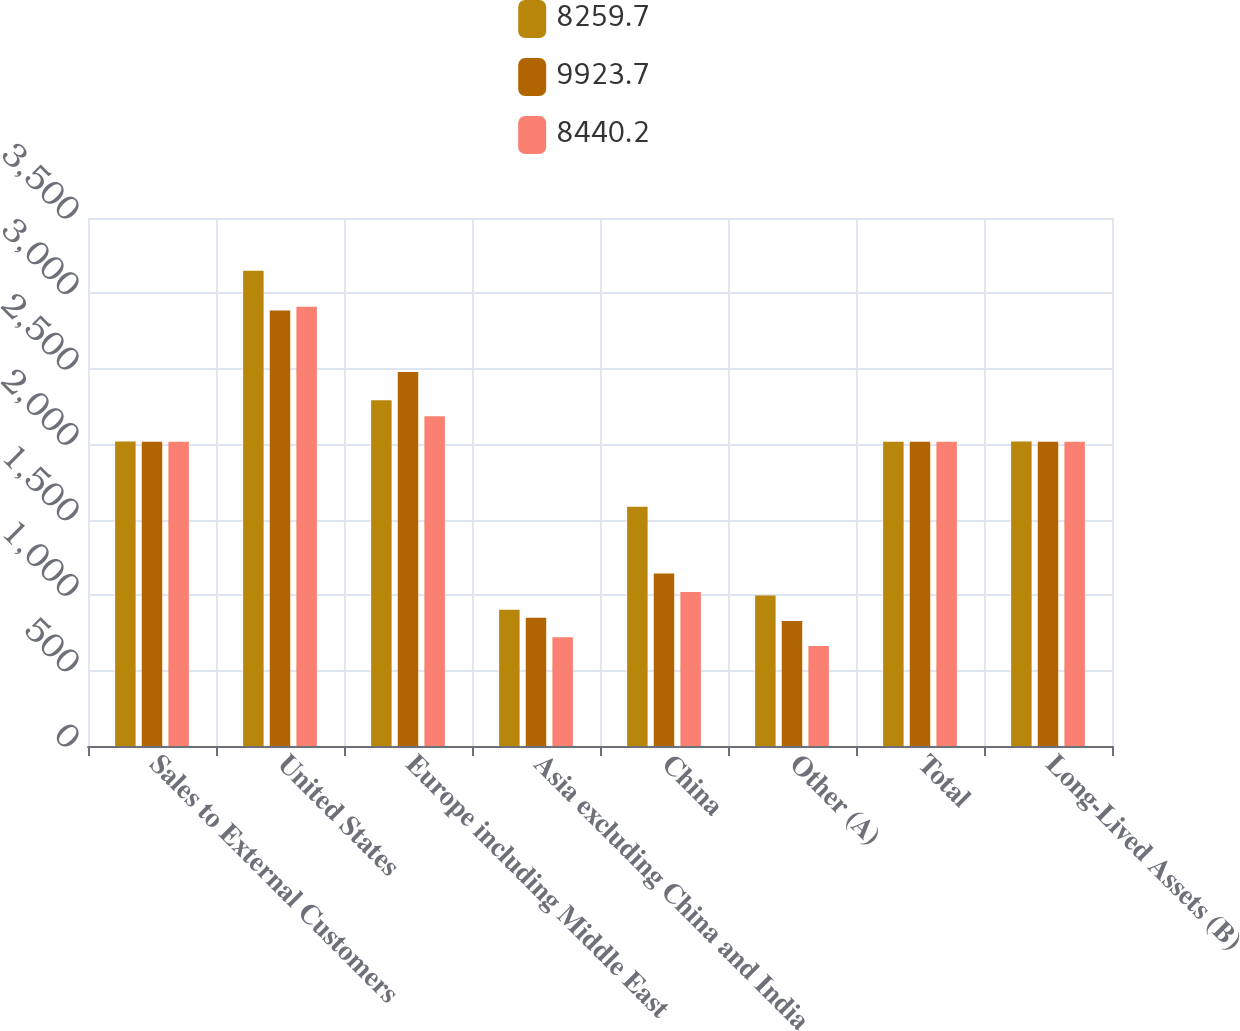Convert chart. <chart><loc_0><loc_0><loc_500><loc_500><stacked_bar_chart><ecel><fcel>Sales to External Customers<fcel>United States<fcel>Europe including Middle East<fcel>Asia excluding China and India<fcel>China<fcel>Other (A)<fcel>Total<fcel>Long-Lived Assets (B)<nl><fcel>8259.7<fcel>2018<fcel>3149.6<fcel>2292.5<fcel>904<fcel>1585.7<fcel>998.4<fcel>2016<fcel>2018<nl><fcel>9923.7<fcel>2017<fcel>2886.8<fcel>2478.5<fcel>849.6<fcel>1143.4<fcel>829.3<fcel>2016<fcel>2017<nl><fcel>8440.2<fcel>2016<fcel>2911.7<fcel>2186.5<fcel>721.4<fcel>1020.4<fcel>663.7<fcel>2016<fcel>2016<nl></chart> 